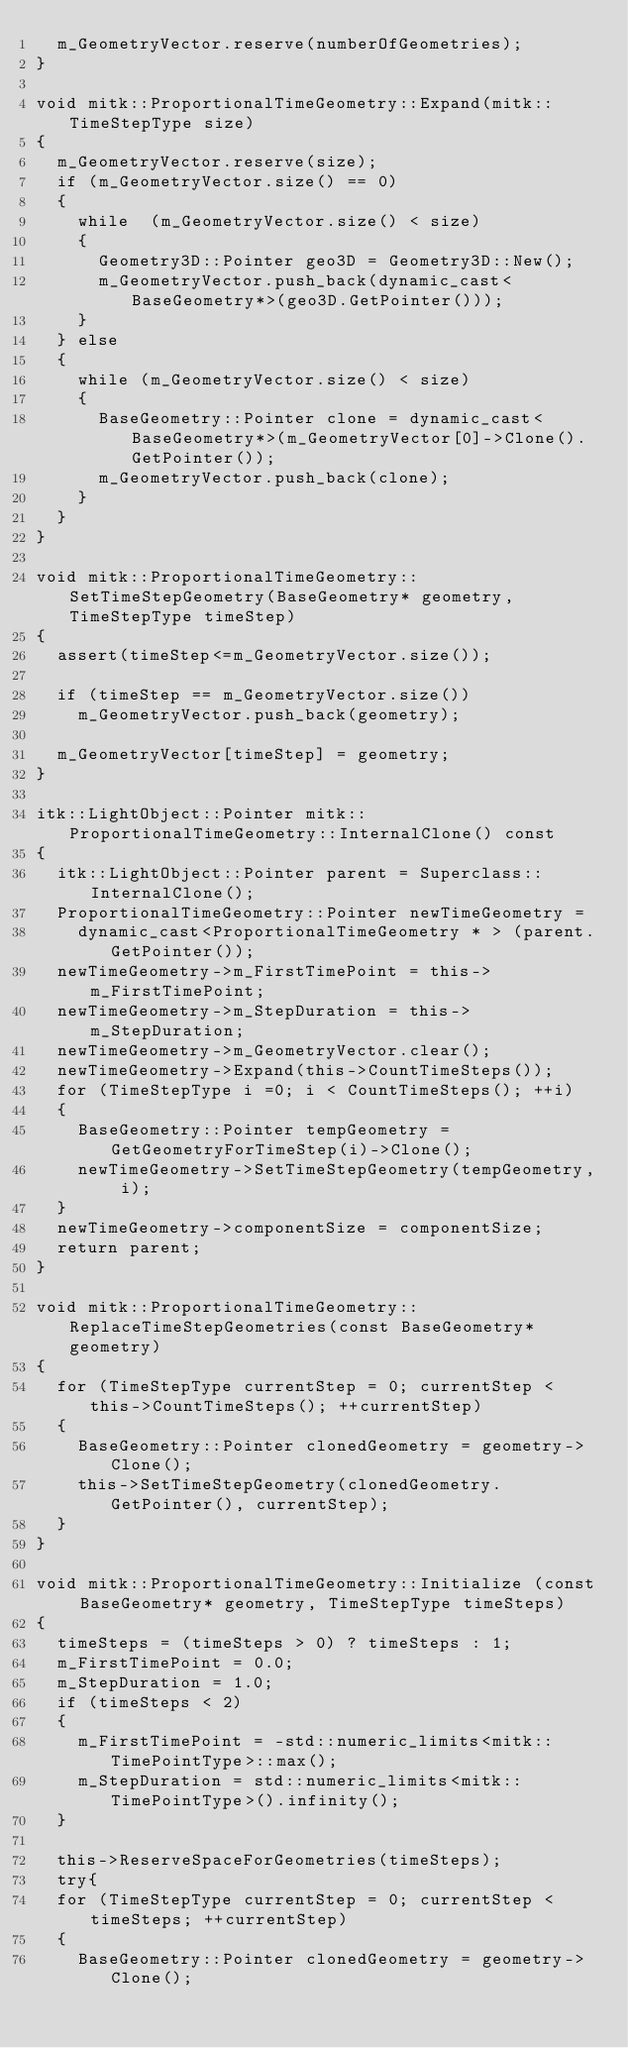Convert code to text. <code><loc_0><loc_0><loc_500><loc_500><_C++_>  m_GeometryVector.reserve(numberOfGeometries);
}

void mitk::ProportionalTimeGeometry::Expand(mitk::TimeStepType size)
{
  m_GeometryVector.reserve(size);
  if (m_GeometryVector.size() == 0)
  {
    while  (m_GeometryVector.size() < size)
    {
      Geometry3D::Pointer geo3D = Geometry3D::New();
      m_GeometryVector.push_back(dynamic_cast<BaseGeometry*>(geo3D.GetPointer()));
    }
  } else
  {
    while (m_GeometryVector.size() < size)
    {
      BaseGeometry::Pointer clone = dynamic_cast<BaseGeometry*>(m_GeometryVector[0]->Clone().GetPointer());
      m_GeometryVector.push_back(clone);
    }
  }
}

void mitk::ProportionalTimeGeometry::SetTimeStepGeometry(BaseGeometry* geometry, TimeStepType timeStep)
{
  assert(timeStep<=m_GeometryVector.size());

  if (timeStep == m_GeometryVector.size())
    m_GeometryVector.push_back(geometry);

  m_GeometryVector[timeStep] = geometry;
}

itk::LightObject::Pointer mitk::ProportionalTimeGeometry::InternalClone() const
{
  itk::LightObject::Pointer parent = Superclass::InternalClone();
  ProportionalTimeGeometry::Pointer newTimeGeometry =
    dynamic_cast<ProportionalTimeGeometry * > (parent.GetPointer());
  newTimeGeometry->m_FirstTimePoint = this->m_FirstTimePoint;
  newTimeGeometry->m_StepDuration = this->m_StepDuration;
  newTimeGeometry->m_GeometryVector.clear();
  newTimeGeometry->Expand(this->CountTimeSteps());
  for (TimeStepType i =0; i < CountTimeSteps(); ++i)
  {
    BaseGeometry::Pointer tempGeometry = GetGeometryForTimeStep(i)->Clone();
    newTimeGeometry->SetTimeStepGeometry(tempGeometry, i);
  }
  newTimeGeometry->componentSize = componentSize;
  return parent;
}

void mitk::ProportionalTimeGeometry::ReplaceTimeStepGeometries(const BaseGeometry* geometry)
{
  for (TimeStepType currentStep = 0; currentStep < this->CountTimeSteps(); ++currentStep)
  {
    BaseGeometry::Pointer clonedGeometry = geometry->Clone();
    this->SetTimeStepGeometry(clonedGeometry.GetPointer(), currentStep);
  }
}

void mitk::ProportionalTimeGeometry::Initialize (const BaseGeometry* geometry, TimeStepType timeSteps)
{
  timeSteps = (timeSteps > 0) ? timeSteps : 1;
  m_FirstTimePoint = 0.0;
  m_StepDuration = 1.0;
  if (timeSteps < 2)
  {
    m_FirstTimePoint = -std::numeric_limits<mitk::TimePointType>::max();
    m_StepDuration = std::numeric_limits<mitk::TimePointType>().infinity();
  }

  this->ReserveSpaceForGeometries(timeSteps);
  try{
  for (TimeStepType currentStep = 0; currentStep < timeSteps; ++currentStep)
  {
    BaseGeometry::Pointer clonedGeometry = geometry->Clone();</code> 